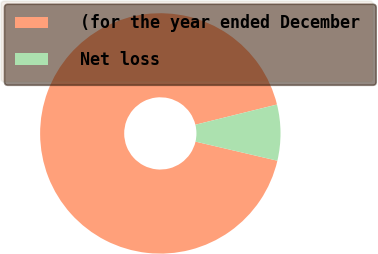<chart> <loc_0><loc_0><loc_500><loc_500><pie_chart><fcel>(for the year ended December<fcel>Net loss<nl><fcel>92.49%<fcel>7.51%<nl></chart> 